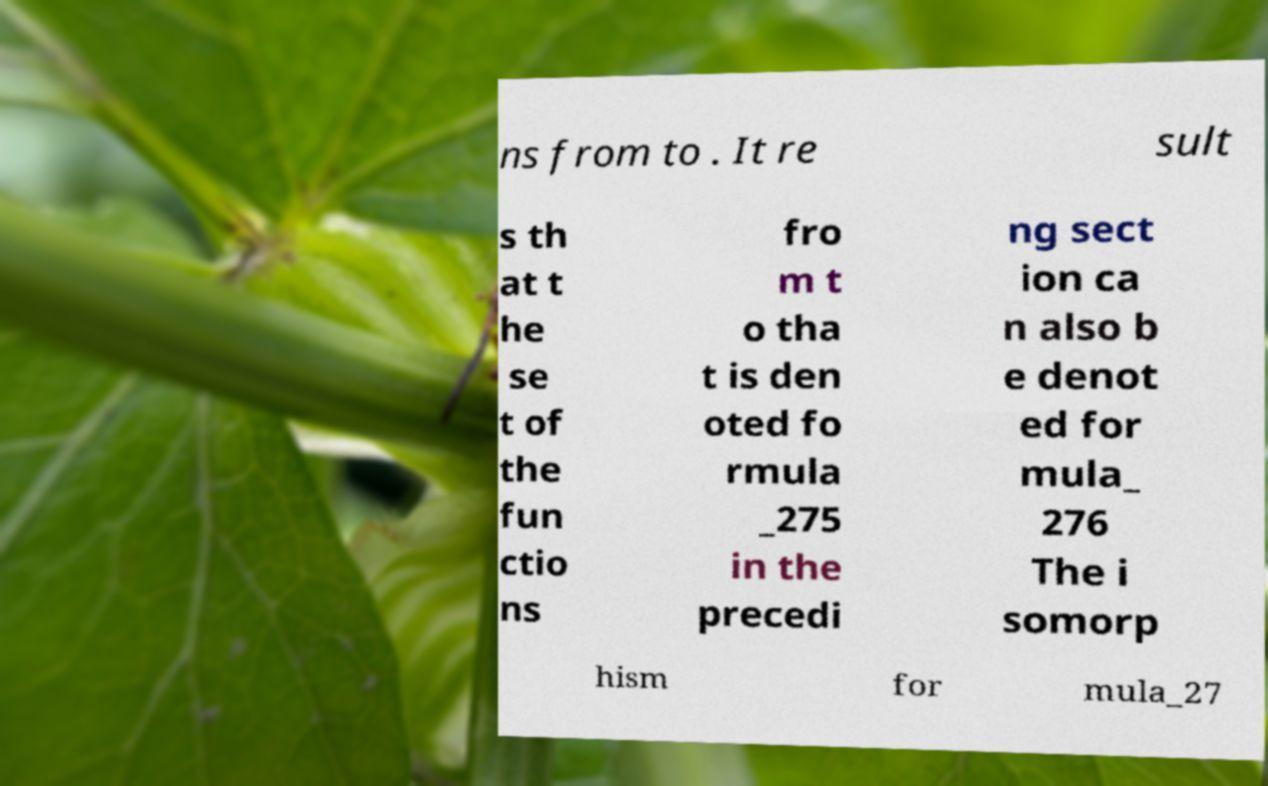There's text embedded in this image that I need extracted. Can you transcribe it verbatim? ns from to . It re sult s th at t he se t of the fun ctio ns fro m t o tha t is den oted fo rmula _275 in the precedi ng sect ion ca n also b e denot ed for mula_ 276 The i somorp hism for mula_27 